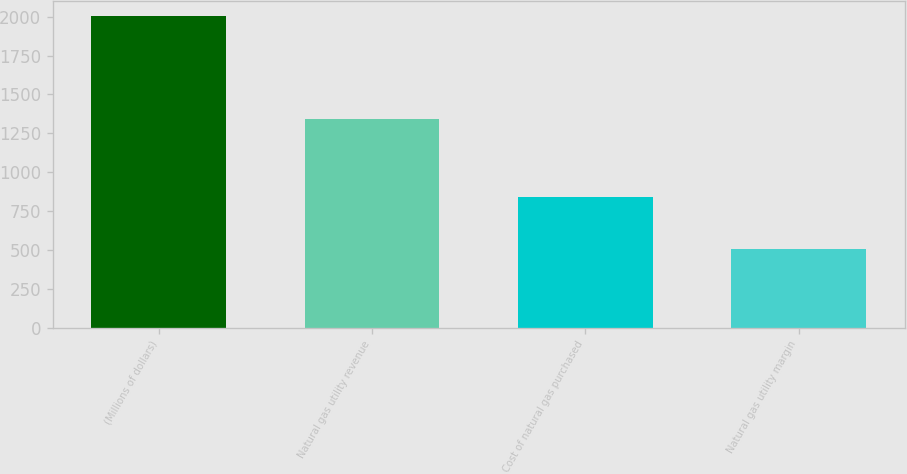<chart> <loc_0><loc_0><loc_500><loc_500><bar_chart><fcel>(Millions of dollars)<fcel>Natural gas utility revenue<fcel>Cost of natural gas purchased<fcel>Natural gas utility margin<nl><fcel>2002<fcel>1341<fcel>838<fcel>503<nl></chart> 